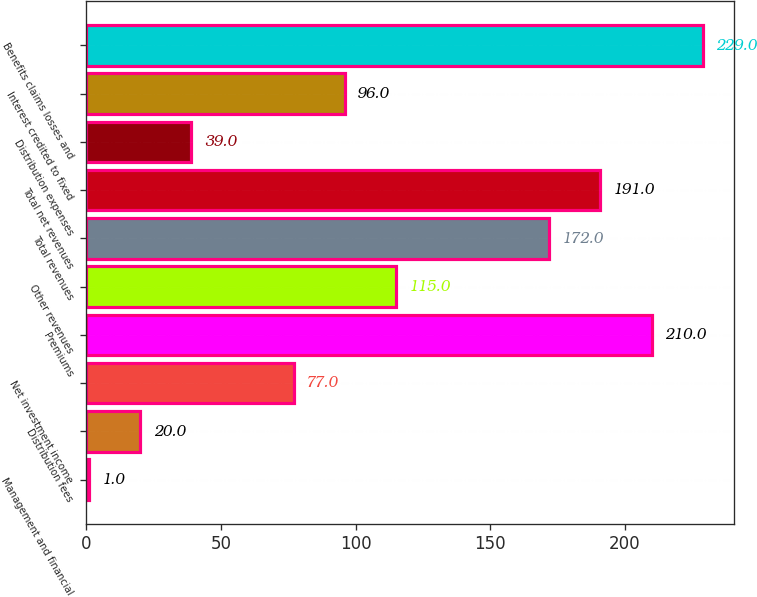Convert chart. <chart><loc_0><loc_0><loc_500><loc_500><bar_chart><fcel>Management and financial<fcel>Distribution fees<fcel>Net investment income<fcel>Premiums<fcel>Other revenues<fcel>Total revenues<fcel>Total net revenues<fcel>Distribution expenses<fcel>Interest credited to fixed<fcel>Benefits claims losses and<nl><fcel>1<fcel>20<fcel>77<fcel>210<fcel>115<fcel>172<fcel>191<fcel>39<fcel>96<fcel>229<nl></chart> 